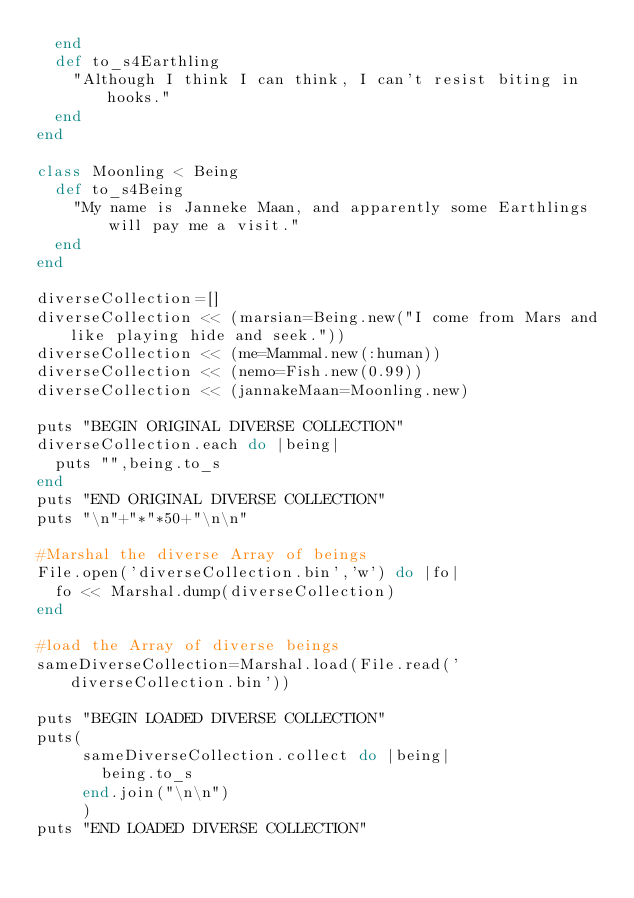<code> <loc_0><loc_0><loc_500><loc_500><_Ruby_>  end
  def to_s4Earthling
    "Although I think I can think, I can't resist biting in hooks."
  end
end

class Moonling < Being
  def to_s4Being
    "My name is Janneke Maan, and apparently some Earthlings will pay me a visit."
  end
end

diverseCollection=[]
diverseCollection << (marsian=Being.new("I come from Mars and like playing hide and seek."))
diverseCollection << (me=Mammal.new(:human))
diverseCollection << (nemo=Fish.new(0.99))
diverseCollection << (jannakeMaan=Moonling.new)

puts "BEGIN ORIGINAL DIVERSE COLLECTION"
diverseCollection.each do |being|
  puts "",being.to_s
end
puts "END ORIGINAL DIVERSE COLLECTION"
puts "\n"+"*"*50+"\n\n"

#Marshal the diverse Array of beings
File.open('diverseCollection.bin','w') do |fo|
  fo << Marshal.dump(diverseCollection)
end

#load the Array of diverse beings
sameDiverseCollection=Marshal.load(File.read('diverseCollection.bin'))

puts "BEGIN LOADED DIVERSE COLLECTION"
puts(
     sameDiverseCollection.collect do |being|
       being.to_s
     end.join("\n\n")
     )
puts "END LOADED DIVERSE COLLECTION"
</code> 